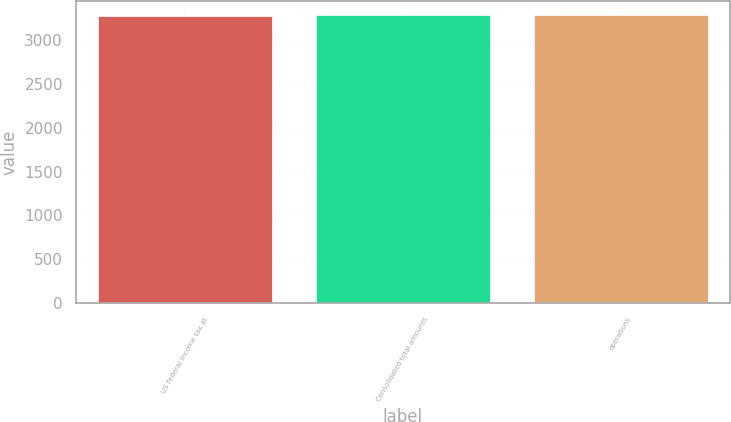<chart> <loc_0><loc_0><loc_500><loc_500><bar_chart><fcel>US federal income tax at<fcel>Consolidated total amounts<fcel>operations<nl><fcel>3281<fcel>3281.1<fcel>3281.2<nl></chart> 